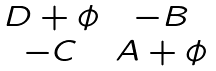Convert formula to latex. <formula><loc_0><loc_0><loc_500><loc_500>\begin{matrix} D + \phi & - B \\ - C & A + \phi \end{matrix}</formula> 